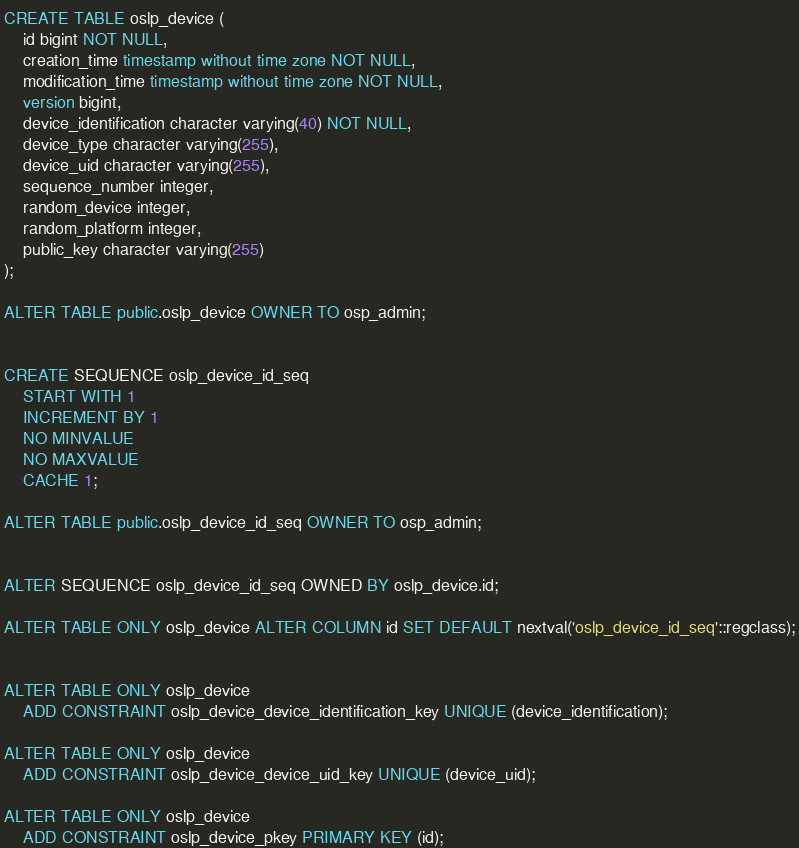<code> <loc_0><loc_0><loc_500><loc_500><_SQL_>CREATE TABLE oslp_device (
    id bigint NOT NULL,
    creation_time timestamp without time zone NOT NULL,
    modification_time timestamp without time zone NOT NULL,
    version bigint,
    device_identification character varying(40) NOT NULL,
    device_type character varying(255),
    device_uid character varying(255),
    sequence_number integer,
    random_device integer,
    random_platform integer,
    public_key character varying(255)
);

ALTER TABLE public.oslp_device OWNER TO osp_admin;


CREATE SEQUENCE oslp_device_id_seq
    START WITH 1
    INCREMENT BY 1
    NO MINVALUE
    NO MAXVALUE
    CACHE 1;

ALTER TABLE public.oslp_device_id_seq OWNER TO osp_admin;


ALTER SEQUENCE oslp_device_id_seq OWNED BY oslp_device.id;

ALTER TABLE ONLY oslp_device ALTER COLUMN id SET DEFAULT nextval('oslp_device_id_seq'::regclass);


ALTER TABLE ONLY oslp_device
    ADD CONSTRAINT oslp_device_device_identification_key UNIQUE (device_identification);
    
ALTER TABLE ONLY oslp_device
    ADD CONSTRAINT oslp_device_device_uid_key UNIQUE (device_uid);
    
ALTER TABLE ONLY oslp_device
    ADD CONSTRAINT oslp_device_pkey PRIMARY KEY (id);</code> 